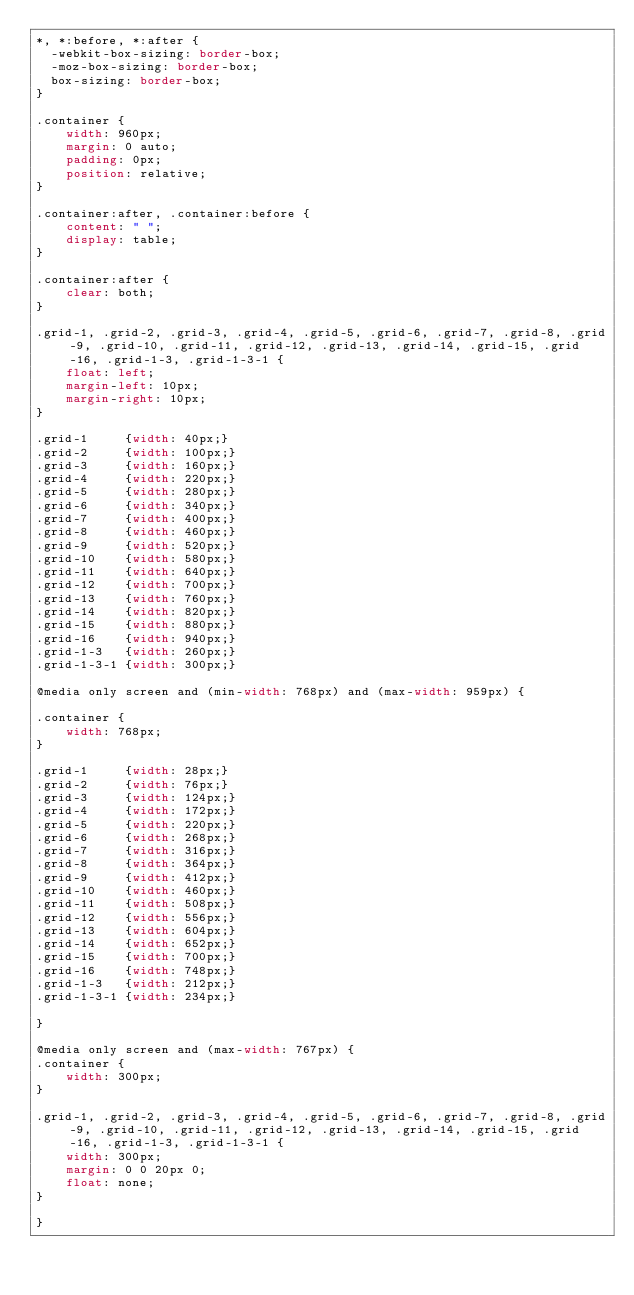<code> <loc_0><loc_0><loc_500><loc_500><_CSS_>*, *:before, *:after {
  -webkit-box-sizing: border-box; 
  -moz-box-sizing: border-box; 
  box-sizing: border-box;
}

.container {
	width: 960px;
	margin: 0 auto;
	padding: 0px;
	position: relative;
}

.container:after, .container:before {
	content: " ";
	display: table;
}

.container:after {
	clear: both;
}

.grid-1, .grid-2, .grid-3, .grid-4, .grid-5, .grid-6, .grid-7, .grid-8, .grid-9, .grid-10, .grid-11, .grid-12, .grid-13, .grid-14, .grid-15, .grid-16, .grid-1-3, .grid-1-3-1 {
	float: left;
	margin-left: 10px;
	margin-right: 10px;
}

.grid-1 	{width: 40px;}
.grid-2 	{width: 100px;}
.grid-3 	{width: 160px;}
.grid-4 	{width: 220px;}
.grid-5 	{width: 280px;}
.grid-6 	{width: 340px;}
.grid-7 	{width: 400px;}
.grid-8 	{width: 460px;}
.grid-9 	{width: 520px;}
.grid-10 	{width: 580px;}
.grid-11 	{width: 640px;}
.grid-12 	{width: 700px;}
.grid-13 	{width: 760px;}
.grid-14 	{width: 820px;}
.grid-15 	{width: 880px;}
.grid-16 	{width: 940px;}
.grid-1-3	{width: 260px;}
.grid-1-3-1 {width: 300px;}

@media only screen and (min-width: 768px) and (max-width: 959px) {

.container {
	width: 768px;
}

.grid-1		{width: 28px;}
.grid-2		{width: 76px;}
.grid-3		{width: 124px;}
.grid-4		{width: 172px;}
.grid-5		{width: 220px;}
.grid-6		{width: 268px;}
.grid-7		{width: 316px;}
.grid-8		{width: 364px;}
.grid-9		{width: 412px;}
.grid-10	{width: 460px;}
.grid-11	{width: 508px;}
.grid-12	{width: 556px;}
.grid-13	{width: 604px;}
.grid-14	{width: 652px;}
.grid-15	{width: 700px;}
.grid-16	{width: 748px;}
.grid-1-3	{width: 212px;}
.grid-1-3-1 {width: 234px;}

}

@media only screen and (max-width: 767px) {
.container {
	width: 300px;
}

.grid-1, .grid-2, .grid-3, .grid-4, .grid-5, .grid-6, .grid-7, .grid-8, .grid-9, .grid-10, .grid-11, .grid-12, .grid-13, .grid-14, .grid-15, .grid-16, .grid-1-3, .grid-1-3-1 {
	width: 300px;
	margin: 0 0 20px 0;
	float: none;
}

}</code> 